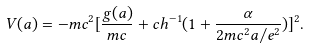Convert formula to latex. <formula><loc_0><loc_0><loc_500><loc_500>V ( a ) = - m c ^ { 2 } [ \frac { g ( a ) } { m c } + c h ^ { - 1 } ( 1 + \frac { \alpha } { 2 m c ^ { 2 } a / e ^ { 2 } } ) ] ^ { 2 } .</formula> 